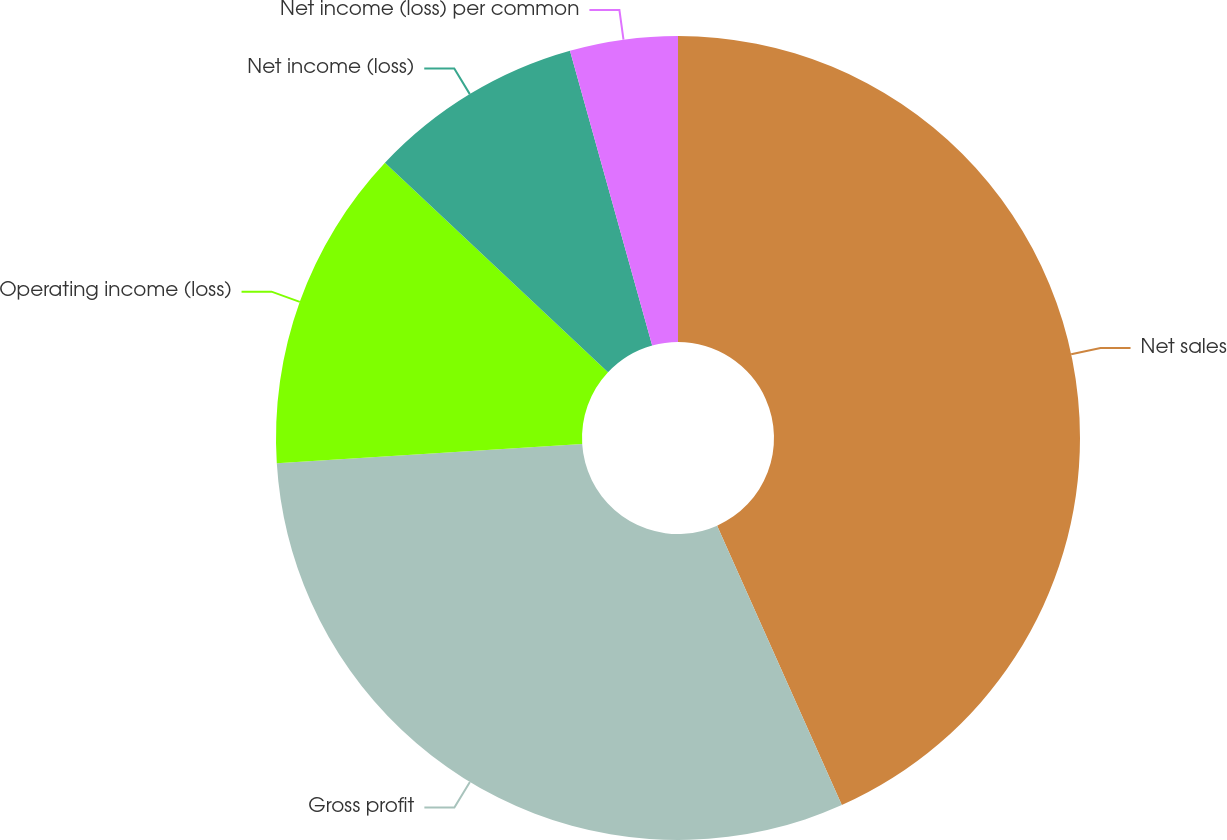Convert chart to OTSL. <chart><loc_0><loc_0><loc_500><loc_500><pie_chart><fcel>Net sales<fcel>Gross profit<fcel>Operating income (loss)<fcel>Net income (loss)<fcel>Net income (loss) per common<nl><fcel>43.32%<fcel>30.68%<fcel>13.0%<fcel>8.67%<fcel>4.33%<nl></chart> 